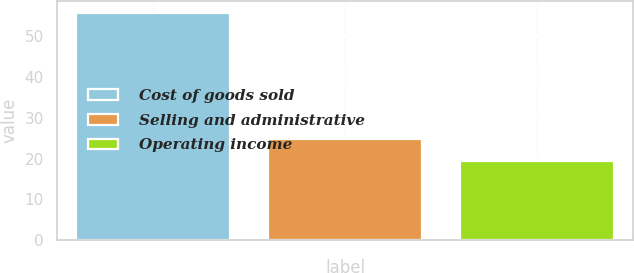Convert chart. <chart><loc_0><loc_0><loc_500><loc_500><bar_chart><fcel>Cost of goods sold<fcel>Selling and administrative<fcel>Operating income<nl><fcel>55.8<fcel>24.8<fcel>19.4<nl></chart> 